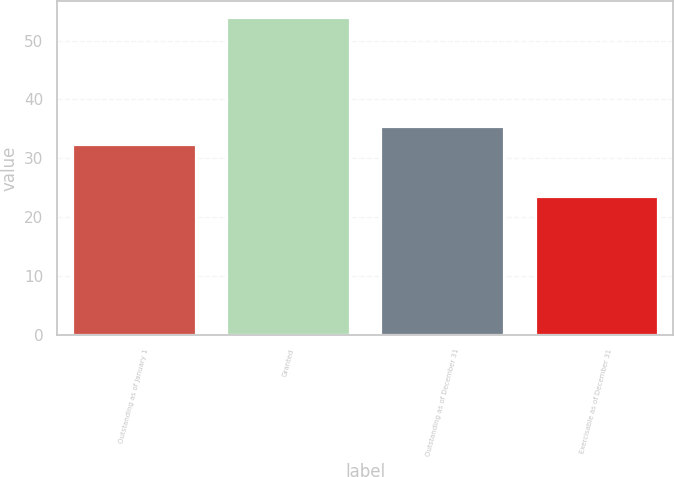Convert chart. <chart><loc_0><loc_0><loc_500><loc_500><bar_chart><fcel>Outstanding as of January 1<fcel>Granted<fcel>Outstanding as of December 31<fcel>Exercisable as of December 31<nl><fcel>32.51<fcel>54<fcel>35.55<fcel>23.61<nl></chart> 